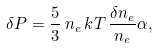<formula> <loc_0><loc_0><loc_500><loc_500>\delta P = \frac { 5 } { 3 } \, n _ { e } \, k T \, \frac { \delta n _ { e } } { n _ { e } } \alpha ,</formula> 